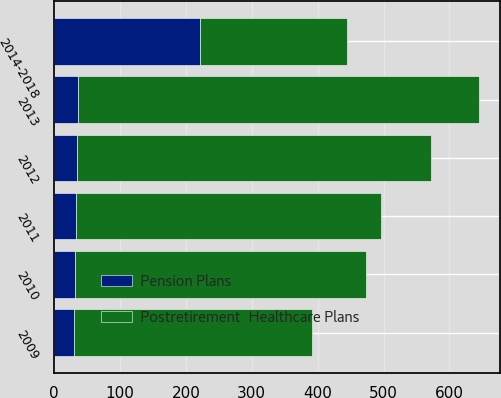Convert chart to OTSL. <chart><loc_0><loc_0><loc_500><loc_500><stacked_bar_chart><ecel><fcel>2009<fcel>2010<fcel>2011<fcel>2012<fcel>2013<fcel>2014-2018<nl><fcel>Postretirement  Healthcare Plans<fcel>362<fcel>442<fcel>463<fcel>537<fcel>609<fcel>222<nl><fcel>Pension Plans<fcel>30<fcel>31<fcel>33<fcel>35<fcel>36<fcel>222<nl></chart> 